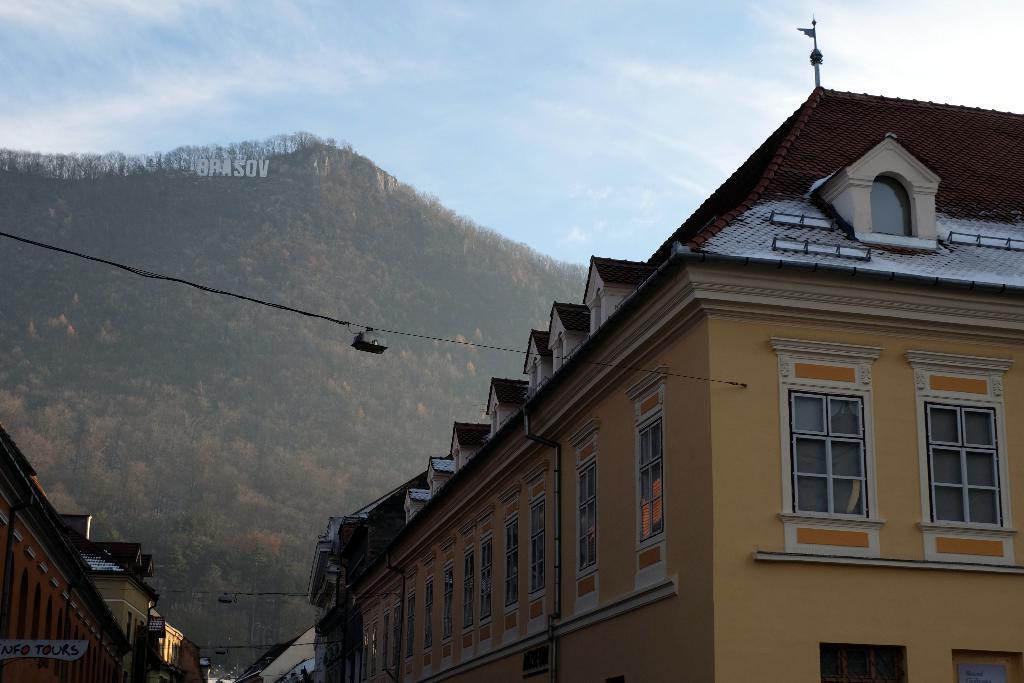How would you summarize this image in a sentence or two? In this image we can see the mountains, some houses, one flag with pole attached at the top of the house, some objects attached to the walls, some wires with lights attached to the houses, one name board with text are on the left side of the image and at the top there is the sky. There are some trees, bushes, plants and grass on the surface. 